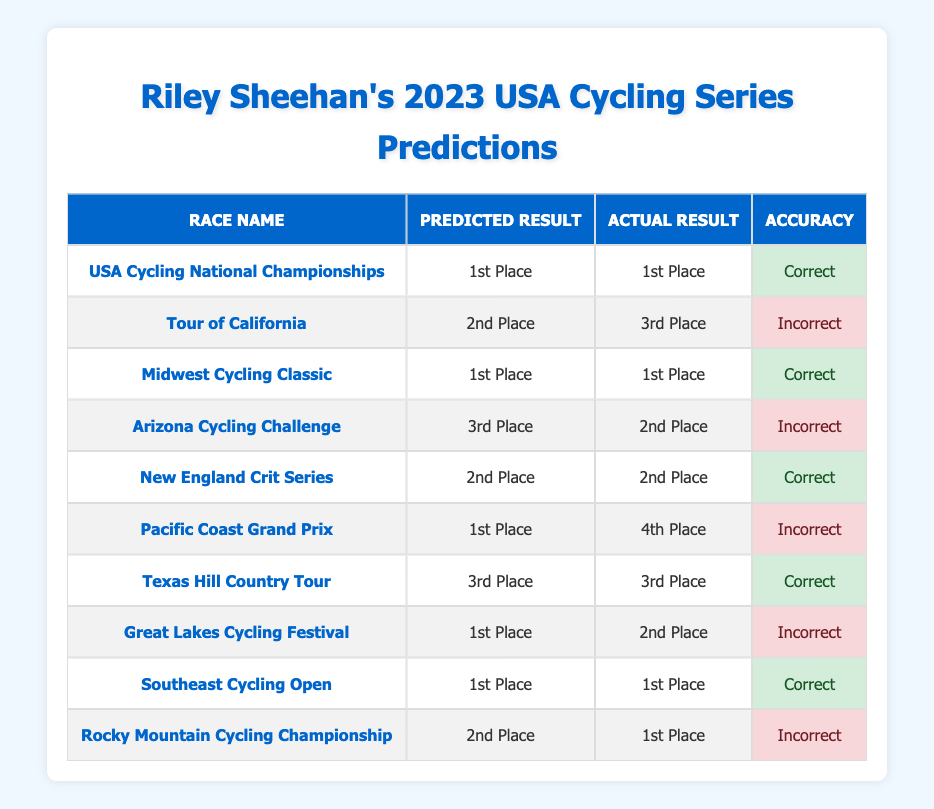What was Riley Sheehan's predicted result for the Tour of California? The table directly shows that the predicted result for the Tour of California was "2nd Place."
Answer: 2nd Place How many races did Riley Sheehan correctly predict his finishing place? To find this, we check the "Accuracy" column for "Correct" entries. There are 5 rows labeled as "Correct."
Answer: 5 Did Riley Sheehan accurately predict his result in the Pacific Coast Grand Prix? Checking the table, the actual result for the Pacific Coast Grand Prix was "4th Place," while the predicted result was "1st Place." Since they do not match, the prediction was incorrect.
Answer: No What percentage of the races did Riley Sheehan incorrectly predict? There are 10 races in total, with 5 incorrect predictions. To find the percentage: (5 incorrect / 10 total) * 100 = 50%.
Answer: 50% What is the total number of races where Riley Sheehan predicted "1st Place"? We examine the "Predicted Result" column and count how many times "1st Place" appears, which is 4 times.
Answer: 4 In which race did Riley Sheehan predict a "3rd Place" finish but finished better than that? The Arizona Cycling Challenge had a predicted 3rd Place, but the actual result was 2nd Place, which indicates he finished better than predicted.
Answer: Arizona Cycling Challenge What was Riley Sheehan's actual finishing result for the Rocky Mountain Cycling Championship? The table shows that the actual result for the Rocky Mountain Cycling Championship was "1st Place."
Answer: 1st Place How many races did Riley Sheehan finish in the same position as he predicted? By checking the "Accuracy" column, we find that there are 5 instances where the predicted and actual results matched.
Answer: 5 What was the predicted result for the Great Lakes Cycling Festival? The table lists the predicted result for the Great Lakes Cycling Festival as "1st Place."
Answer: 1st Place 